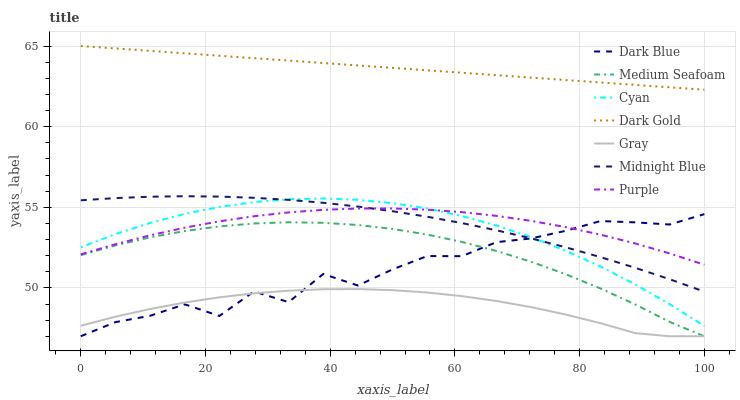Does Gray have the minimum area under the curve?
Answer yes or no. Yes. Does Dark Gold have the maximum area under the curve?
Answer yes or no. Yes. Does Midnight Blue have the minimum area under the curve?
Answer yes or no. No. Does Midnight Blue have the maximum area under the curve?
Answer yes or no. No. Is Dark Gold the smoothest?
Answer yes or no. Yes. Is Dark Blue the roughest?
Answer yes or no. Yes. Is Midnight Blue the smoothest?
Answer yes or no. No. Is Midnight Blue the roughest?
Answer yes or no. No. Does Midnight Blue have the lowest value?
Answer yes or no. No. Does Dark Gold have the highest value?
Answer yes or no. Yes. Does Midnight Blue have the highest value?
Answer yes or no. No. Is Medium Seafoam less than Midnight Blue?
Answer yes or no. Yes. Is Midnight Blue greater than Medium Seafoam?
Answer yes or no. Yes. Does Cyan intersect Dark Blue?
Answer yes or no. Yes. Is Cyan less than Dark Blue?
Answer yes or no. No. Is Cyan greater than Dark Blue?
Answer yes or no. No. Does Medium Seafoam intersect Midnight Blue?
Answer yes or no. No. 